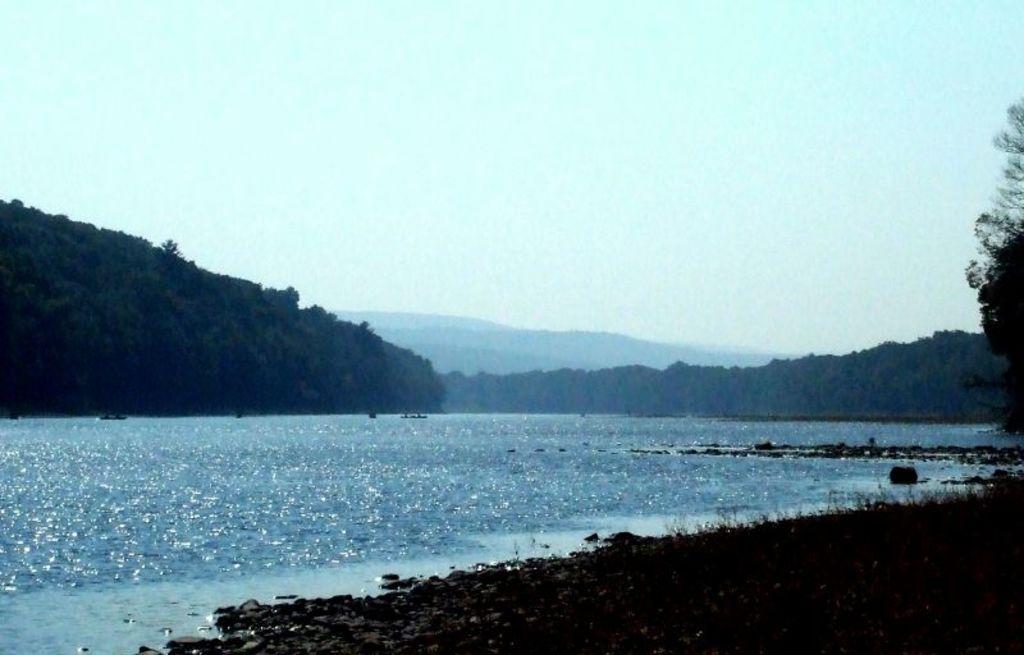Can you describe this image briefly? In this picture we can see water, trees, hills and a sky. 